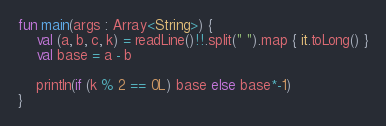<code> <loc_0><loc_0><loc_500><loc_500><_Kotlin_>fun main(args : Array<String>) {
    val (a, b, c, k) = readLine()!!.split(" ").map { it.toLong() }
    val base = a - b

    println(if (k % 2 == 0L) base else base*-1)
}</code> 